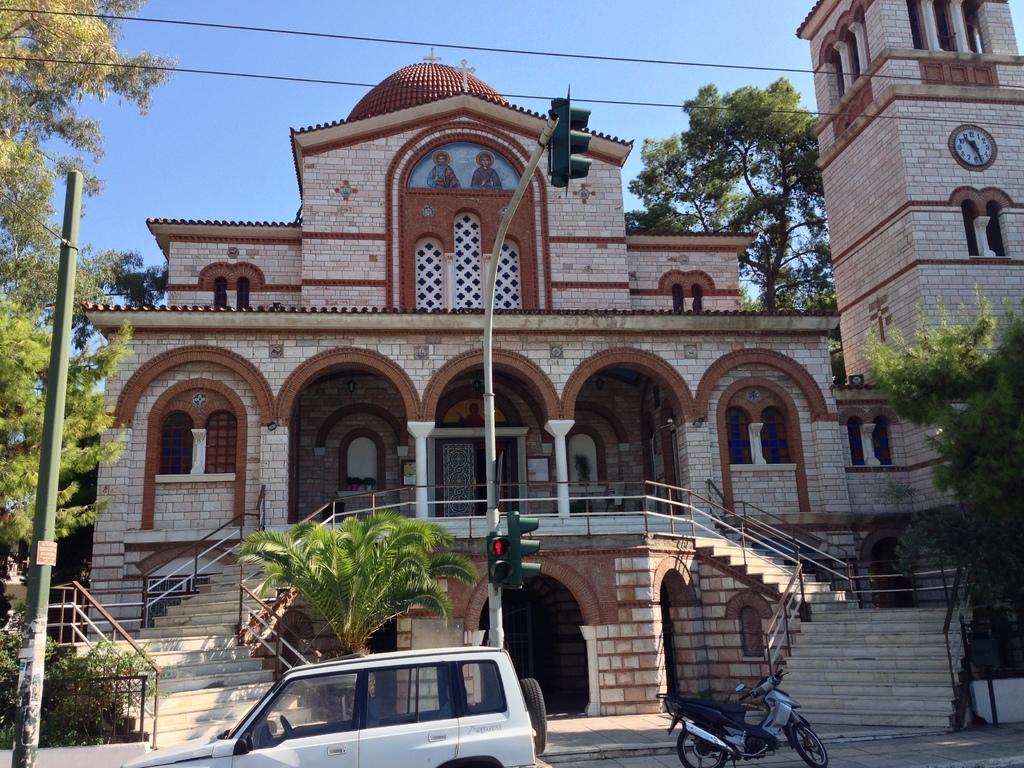Describe this image in one or two sentences. This is an outside view. At the bottom of the image I can see a car and a bike on the road. Beside the road, I can see a traffic signal pole. In the background there is a building and trees. On the right side, I can see a clock tower. At the top I can see the sky along with the wires. 